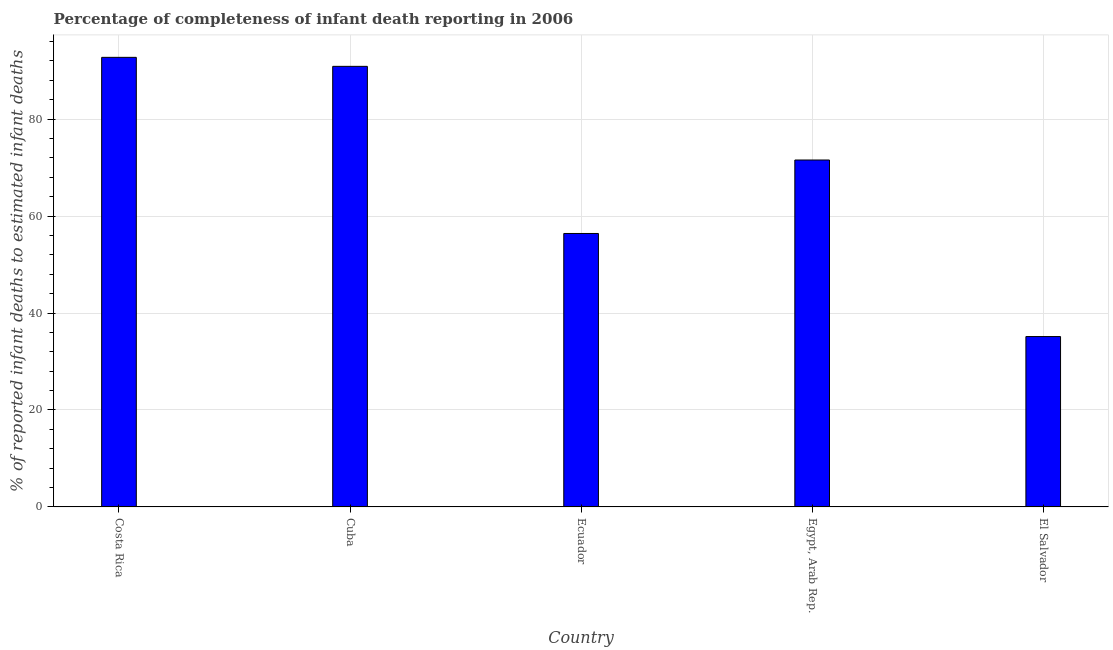Does the graph contain grids?
Your answer should be compact. Yes. What is the title of the graph?
Your response must be concise. Percentage of completeness of infant death reporting in 2006. What is the label or title of the X-axis?
Offer a terse response. Country. What is the label or title of the Y-axis?
Offer a very short reply. % of reported infant deaths to estimated infant deaths. What is the completeness of infant death reporting in El Salvador?
Provide a succinct answer. 35.15. Across all countries, what is the maximum completeness of infant death reporting?
Your answer should be very brief. 92.75. Across all countries, what is the minimum completeness of infant death reporting?
Your response must be concise. 35.15. In which country was the completeness of infant death reporting minimum?
Your response must be concise. El Salvador. What is the sum of the completeness of infant death reporting?
Give a very brief answer. 346.78. What is the difference between the completeness of infant death reporting in Ecuador and Egypt, Arab Rep.?
Offer a terse response. -15.16. What is the average completeness of infant death reporting per country?
Give a very brief answer. 69.36. What is the median completeness of infant death reporting?
Provide a short and direct response. 71.57. In how many countries, is the completeness of infant death reporting greater than 56 %?
Keep it short and to the point. 4. What is the ratio of the completeness of infant death reporting in Costa Rica to that in Ecuador?
Offer a very short reply. 1.64. What is the difference between the highest and the second highest completeness of infant death reporting?
Your response must be concise. 1.86. What is the difference between the highest and the lowest completeness of infant death reporting?
Offer a terse response. 57.6. In how many countries, is the completeness of infant death reporting greater than the average completeness of infant death reporting taken over all countries?
Your answer should be very brief. 3. What is the difference between two consecutive major ticks on the Y-axis?
Your answer should be very brief. 20. Are the values on the major ticks of Y-axis written in scientific E-notation?
Keep it short and to the point. No. What is the % of reported infant deaths to estimated infant deaths in Costa Rica?
Your answer should be compact. 92.75. What is the % of reported infant deaths to estimated infant deaths in Cuba?
Give a very brief answer. 90.9. What is the % of reported infant deaths to estimated infant deaths in Ecuador?
Make the answer very short. 56.42. What is the % of reported infant deaths to estimated infant deaths of Egypt, Arab Rep.?
Your answer should be very brief. 71.57. What is the % of reported infant deaths to estimated infant deaths of El Salvador?
Keep it short and to the point. 35.15. What is the difference between the % of reported infant deaths to estimated infant deaths in Costa Rica and Cuba?
Keep it short and to the point. 1.86. What is the difference between the % of reported infant deaths to estimated infant deaths in Costa Rica and Ecuador?
Make the answer very short. 36.34. What is the difference between the % of reported infant deaths to estimated infant deaths in Costa Rica and Egypt, Arab Rep.?
Keep it short and to the point. 21.18. What is the difference between the % of reported infant deaths to estimated infant deaths in Costa Rica and El Salvador?
Provide a succinct answer. 57.6. What is the difference between the % of reported infant deaths to estimated infant deaths in Cuba and Ecuador?
Make the answer very short. 34.48. What is the difference between the % of reported infant deaths to estimated infant deaths in Cuba and Egypt, Arab Rep.?
Offer a terse response. 19.32. What is the difference between the % of reported infant deaths to estimated infant deaths in Cuba and El Salvador?
Your answer should be very brief. 55.75. What is the difference between the % of reported infant deaths to estimated infant deaths in Ecuador and Egypt, Arab Rep.?
Provide a succinct answer. -15.16. What is the difference between the % of reported infant deaths to estimated infant deaths in Ecuador and El Salvador?
Give a very brief answer. 21.27. What is the difference between the % of reported infant deaths to estimated infant deaths in Egypt, Arab Rep. and El Salvador?
Your answer should be compact. 36.42. What is the ratio of the % of reported infant deaths to estimated infant deaths in Costa Rica to that in Cuba?
Make the answer very short. 1.02. What is the ratio of the % of reported infant deaths to estimated infant deaths in Costa Rica to that in Ecuador?
Offer a terse response. 1.64. What is the ratio of the % of reported infant deaths to estimated infant deaths in Costa Rica to that in Egypt, Arab Rep.?
Provide a short and direct response. 1.3. What is the ratio of the % of reported infant deaths to estimated infant deaths in Costa Rica to that in El Salvador?
Offer a very short reply. 2.64. What is the ratio of the % of reported infant deaths to estimated infant deaths in Cuba to that in Ecuador?
Provide a short and direct response. 1.61. What is the ratio of the % of reported infant deaths to estimated infant deaths in Cuba to that in Egypt, Arab Rep.?
Provide a succinct answer. 1.27. What is the ratio of the % of reported infant deaths to estimated infant deaths in Cuba to that in El Salvador?
Offer a terse response. 2.59. What is the ratio of the % of reported infant deaths to estimated infant deaths in Ecuador to that in Egypt, Arab Rep.?
Offer a terse response. 0.79. What is the ratio of the % of reported infant deaths to estimated infant deaths in Ecuador to that in El Salvador?
Offer a terse response. 1.6. What is the ratio of the % of reported infant deaths to estimated infant deaths in Egypt, Arab Rep. to that in El Salvador?
Give a very brief answer. 2.04. 